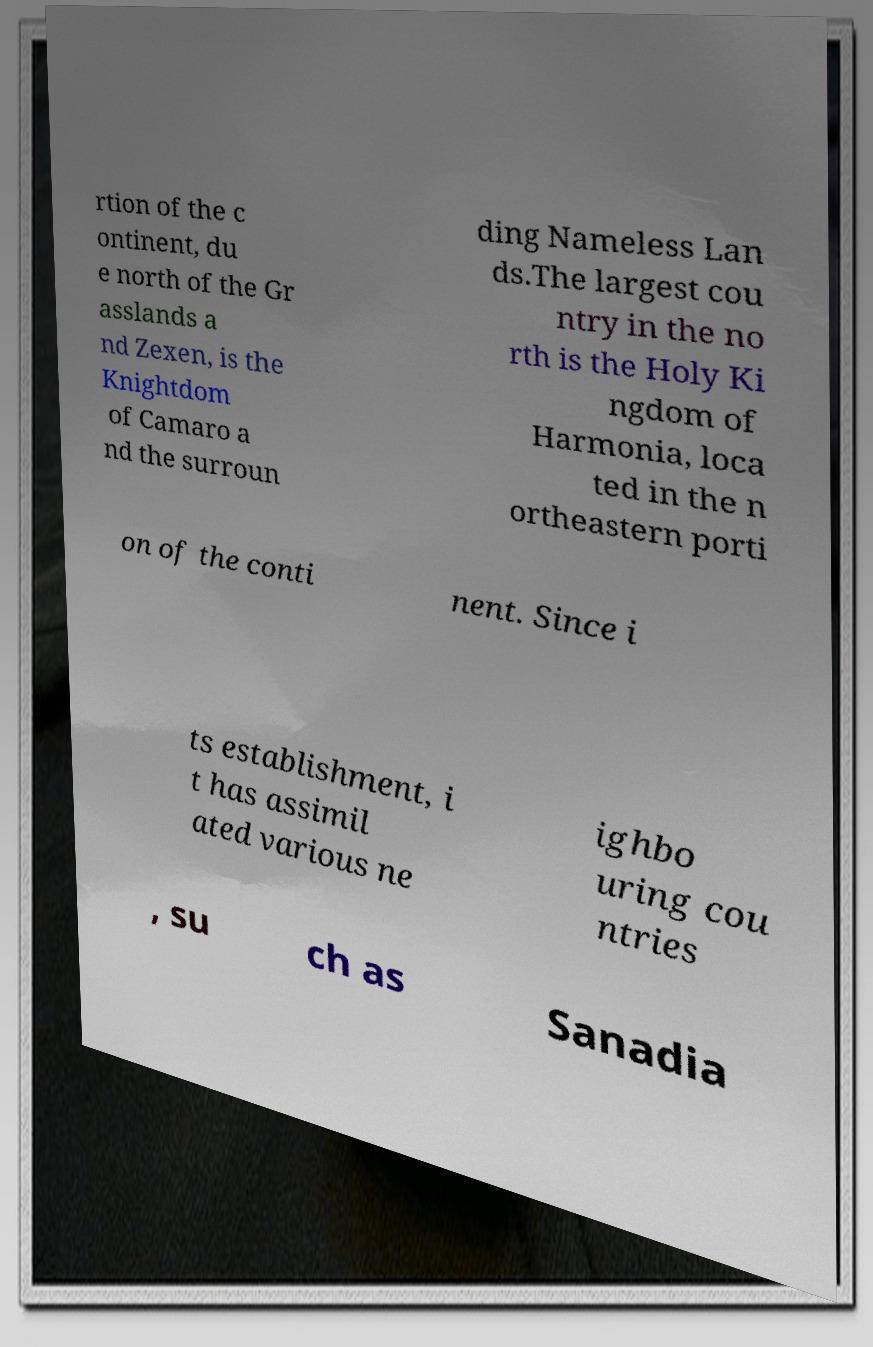Can you read and provide the text displayed in the image?This photo seems to have some interesting text. Can you extract and type it out for me? rtion of the c ontinent, du e north of the Gr asslands a nd Zexen, is the Knightdom of Camaro a nd the surroun ding Nameless Lan ds.The largest cou ntry in the no rth is the Holy Ki ngdom of Harmonia, loca ted in the n ortheastern porti on of the conti nent. Since i ts establishment, i t has assimil ated various ne ighbo uring cou ntries , su ch as Sanadia 